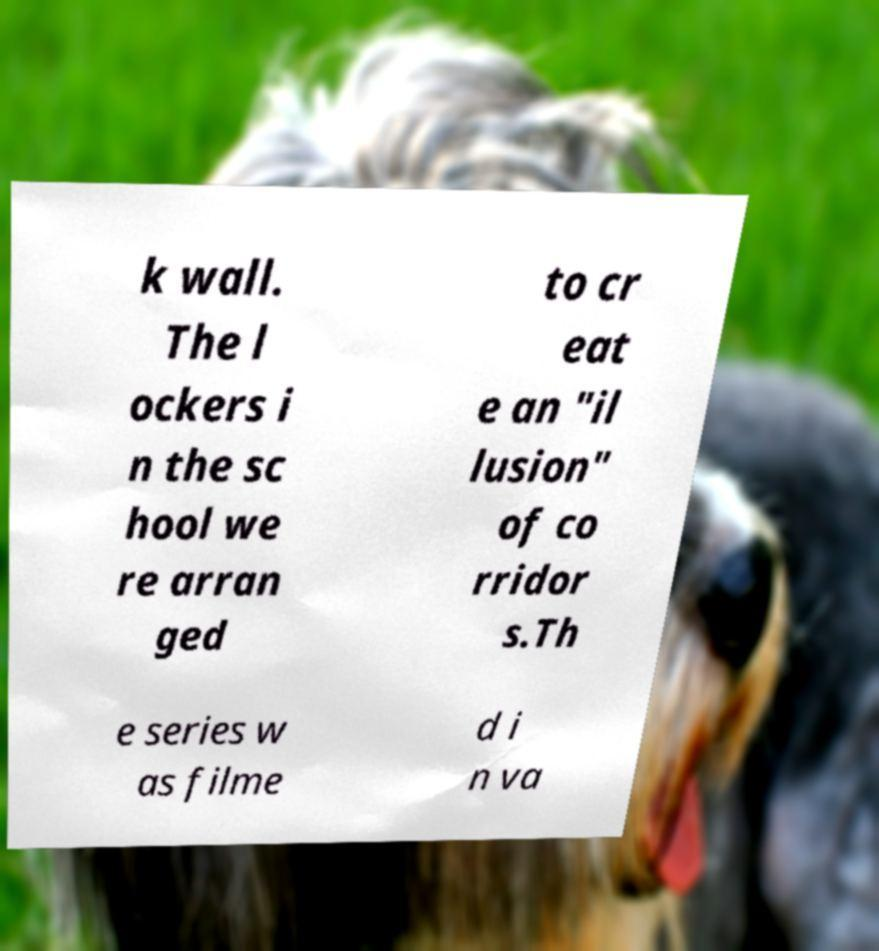Please read and relay the text visible in this image. What does it say? k wall. The l ockers i n the sc hool we re arran ged to cr eat e an "il lusion" of co rridor s.Th e series w as filme d i n va 